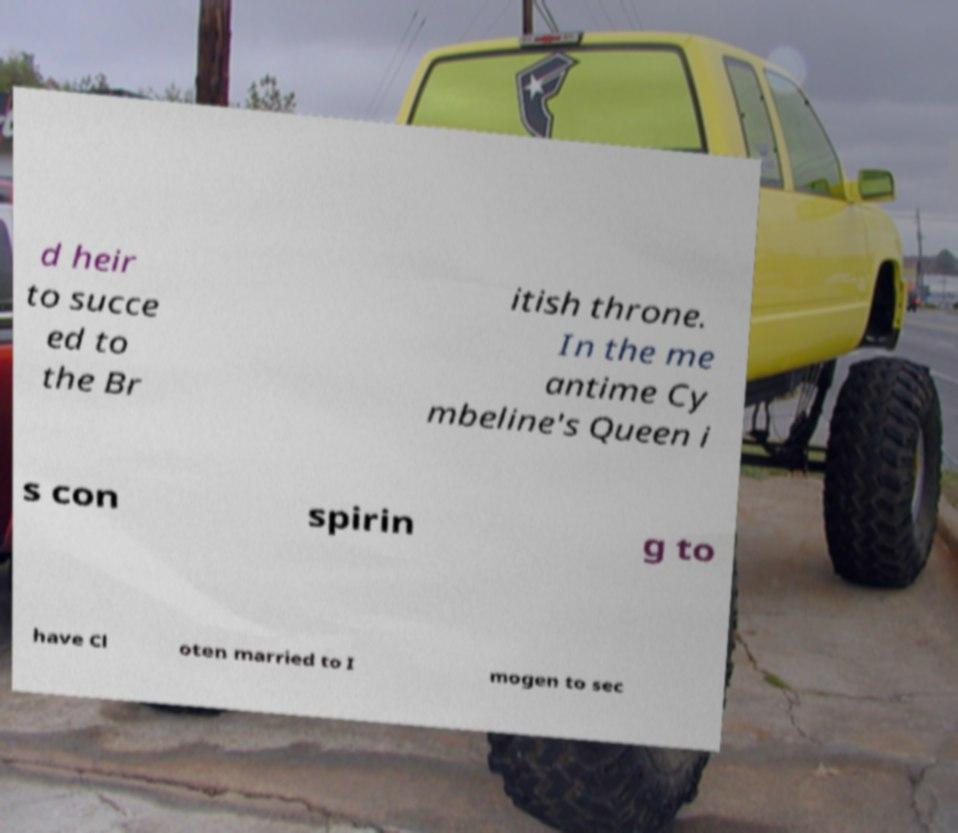Can you read and provide the text displayed in the image?This photo seems to have some interesting text. Can you extract and type it out for me? d heir to succe ed to the Br itish throne. In the me antime Cy mbeline's Queen i s con spirin g to have Cl oten married to I mogen to sec 